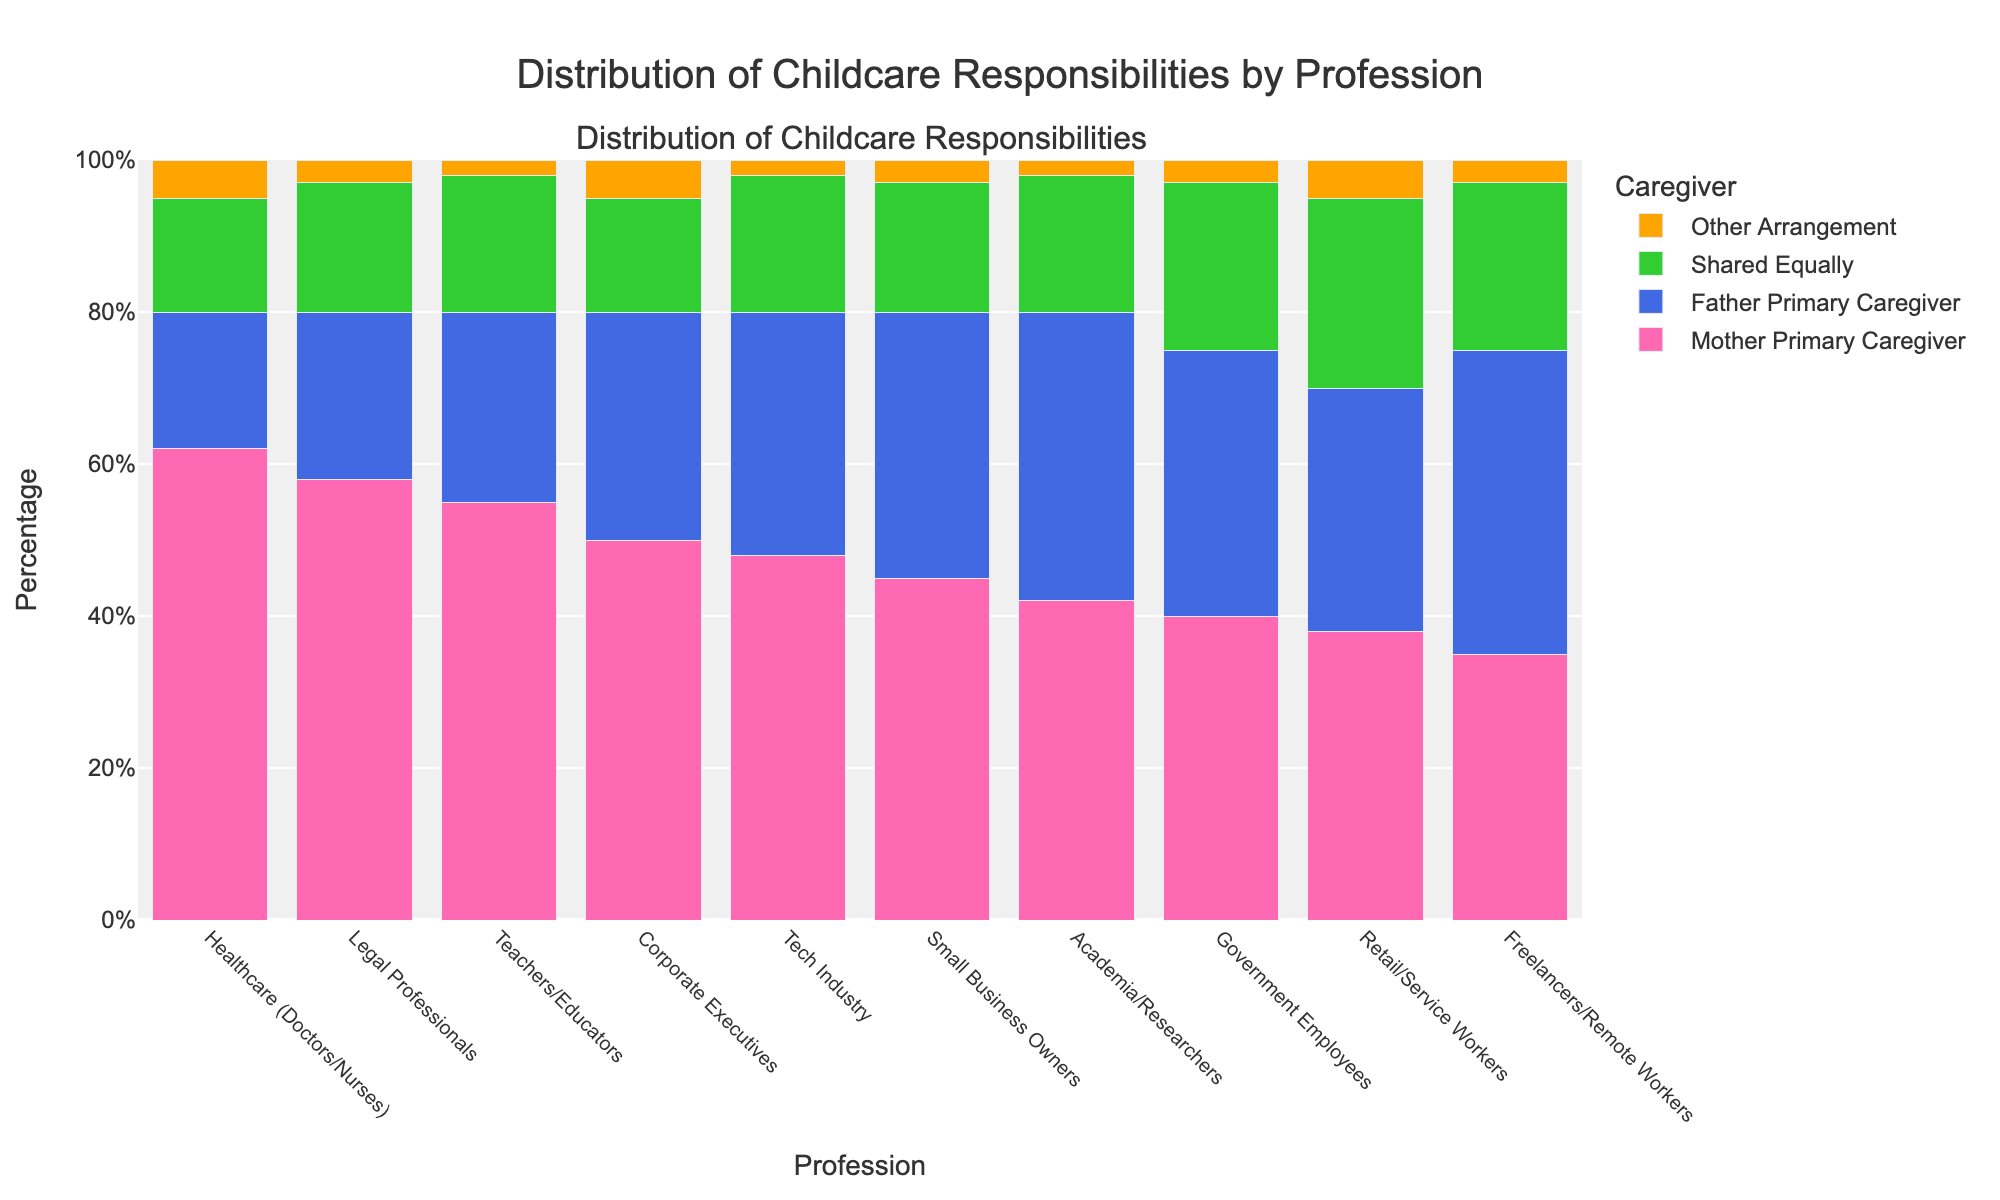What's the difference in the percentage of mothers as the primary caregiver between Healthcare professionals and Freelancers/Remote Workers? The percentage of mothers as the primary caregiver for Healthcare professionals is 62%. For Freelancers/Remote Workers, it is 35%. The difference between these percentages is 62 - 35 = 27%.
Answer: 27% Which profession has the highest percentage of fathers as the primary caregiver? By examining the heights of the bars labeled "Father Primary Caregiver" for each profession, we see that Freelancers/Remote Workers have the highest percentage at 40%.
Answer: Freelancers/Remote Workers In which profession is the childcare responsibility shared equally the most? By looking at the bar representing "Shared Equally" for each profession, Retail/Service Workers have the highest percentage, which is 25%.
Answer: Retail/Service Workers Among Legal Professionals and Teachers/Educators, who reports more 'Other Arrangement' for childcare? The ‘Other Arrangement’ bar is higher for Legal Professionals (3%) than for Teachers/Educators (2%).
Answer: Legal Professionals What is the total percentage of childcare responsibilities predominantly undertaken by fathers and shared equally combined in the Tech industry? In the Tech industry, the percentage for ‘Father Primary Caregiver’ is 32% and 'Shared Equally' is 18%. Summing these gives 32 + 18 = 50%.
Answer: 50% Which profession shows the lowest percentage of mothers as the primary caregiver? Comparing all professions, Freelancers/Remote Workers have the lowest bar at 35%.
Answer: Freelancers/Remote Workers Does the Academia/Researchers profession have a higher percentage of fathers as primary caregivers or shared equally? The percentage of fathers as primary caregivers in Academia/Researchers is 38%, while the shared equally percentage is 18%. Fathers as primary caregivers is higher.
Answer: Fathers as primary caregivers What is the ratio of mothers as primary caregivers to fathers as primary caregivers in the Corporate Executives profession? For Corporate Executives, mothers as primary caregivers is 50% and fathers are 30%. The ratio is calculated as 50/30 = 5/3 or approximately 1.67.
Answer: 1.67 Which of the following professions has the closest percentage of shared childcare responsibilities: Healthcare professionals and Government Employees or Small Business Owners and Freelancers/Remote Workers? Both Healthcare professionals and Government Employees have percentages of 15% and 22% respectively (difference of 7%). Small Business Owners and Freelancers/Remote Workers have percentages of 17% and 22% respectively (difference of 5%). The latter pair has the closer percentage.
Answer: Small Business Owners and Freelancers/Remote Workers Amongst all the professions listed, what is the overall trend in the distribution of childcare responsibilities between mothers and fathers? Generally, mothers predominantly take on the primary caregiving role in all professions. Fathers are gradually becoming more involved, either as primary caregivers or sharing equally. In most fields, the mothers' percentage is often the highest, followed by fathers, shared equally, and 'other' arrangements.
Answer: Mothers predominantly primary caregivers 